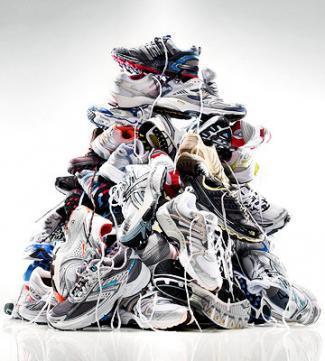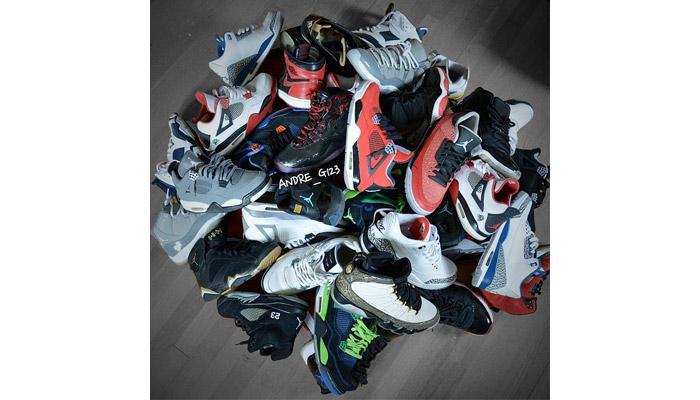The first image is the image on the left, the second image is the image on the right. Evaluate the accuracy of this statement regarding the images: "Shoes are piled up together in the image on the right.". Is it true? Answer yes or no. Yes. The first image is the image on the left, the second image is the image on the right. Given the left and right images, does the statement "One image shows a pair of sneakers and the other shows a shoe pyramid." hold true? Answer yes or no. No. 